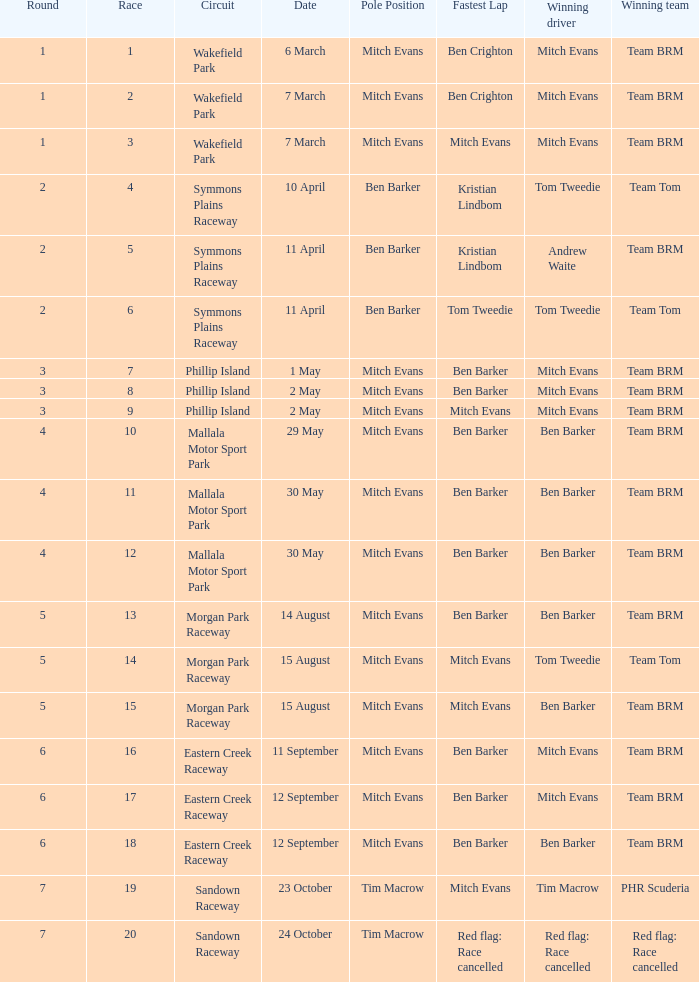In how many rounds was Race 17? 1.0. 